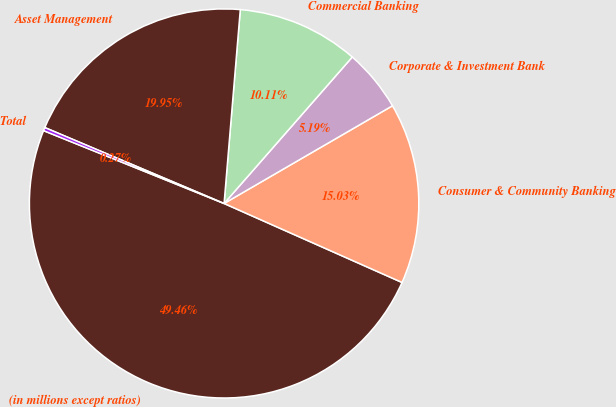<chart> <loc_0><loc_0><loc_500><loc_500><pie_chart><fcel>(in millions except ratios)<fcel>Consumer & Community Banking<fcel>Corporate & Investment Bank<fcel>Commercial Banking<fcel>Asset Management<fcel>Total<nl><fcel>49.46%<fcel>15.03%<fcel>5.19%<fcel>10.11%<fcel>19.95%<fcel>0.27%<nl></chart> 